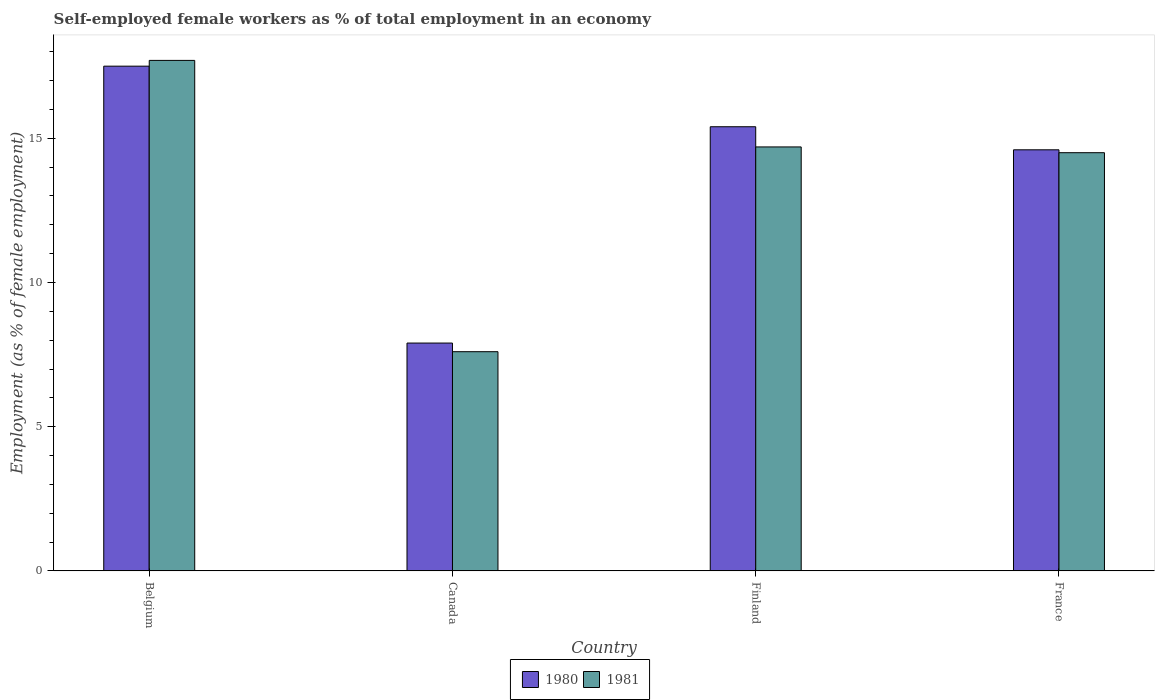How many different coloured bars are there?
Ensure brevity in your answer.  2. How many bars are there on the 1st tick from the right?
Offer a very short reply. 2. In how many cases, is the number of bars for a given country not equal to the number of legend labels?
Keep it short and to the point. 0. What is the percentage of self-employed female workers in 1980 in Finland?
Your answer should be compact. 15.4. Across all countries, what is the maximum percentage of self-employed female workers in 1981?
Provide a succinct answer. 17.7. Across all countries, what is the minimum percentage of self-employed female workers in 1981?
Keep it short and to the point. 7.6. In which country was the percentage of self-employed female workers in 1980 maximum?
Make the answer very short. Belgium. In which country was the percentage of self-employed female workers in 1981 minimum?
Offer a terse response. Canada. What is the total percentage of self-employed female workers in 1981 in the graph?
Make the answer very short. 54.5. What is the difference between the percentage of self-employed female workers in 1980 in Finland and that in France?
Your answer should be compact. 0.8. What is the difference between the percentage of self-employed female workers in 1981 in France and the percentage of self-employed female workers in 1980 in Canada?
Offer a very short reply. 6.6. What is the average percentage of self-employed female workers in 1980 per country?
Your answer should be very brief. 13.85. What is the difference between the percentage of self-employed female workers of/in 1980 and percentage of self-employed female workers of/in 1981 in Finland?
Ensure brevity in your answer.  0.7. What is the ratio of the percentage of self-employed female workers in 1981 in Belgium to that in France?
Your answer should be very brief. 1.22. Is the percentage of self-employed female workers in 1980 in Canada less than that in France?
Keep it short and to the point. Yes. Is the difference between the percentage of self-employed female workers in 1980 in Canada and France greater than the difference between the percentage of self-employed female workers in 1981 in Canada and France?
Offer a terse response. Yes. What is the difference between the highest and the second highest percentage of self-employed female workers in 1980?
Ensure brevity in your answer.  2.9. What is the difference between the highest and the lowest percentage of self-employed female workers in 1980?
Provide a short and direct response. 9.6. In how many countries, is the percentage of self-employed female workers in 1981 greater than the average percentage of self-employed female workers in 1981 taken over all countries?
Provide a short and direct response. 3. Is the sum of the percentage of self-employed female workers in 1981 in Finland and France greater than the maximum percentage of self-employed female workers in 1980 across all countries?
Your response must be concise. Yes. What does the 1st bar from the left in Canada represents?
Provide a short and direct response. 1980. Are all the bars in the graph horizontal?
Make the answer very short. No. How many countries are there in the graph?
Provide a short and direct response. 4. What is the difference between two consecutive major ticks on the Y-axis?
Ensure brevity in your answer.  5. Does the graph contain any zero values?
Your response must be concise. No. Where does the legend appear in the graph?
Offer a terse response. Bottom center. How are the legend labels stacked?
Give a very brief answer. Horizontal. What is the title of the graph?
Your answer should be very brief. Self-employed female workers as % of total employment in an economy. What is the label or title of the Y-axis?
Your response must be concise. Employment (as % of female employment). What is the Employment (as % of female employment) in 1981 in Belgium?
Provide a succinct answer. 17.7. What is the Employment (as % of female employment) of 1980 in Canada?
Ensure brevity in your answer.  7.9. What is the Employment (as % of female employment) of 1981 in Canada?
Give a very brief answer. 7.6. What is the Employment (as % of female employment) in 1980 in Finland?
Provide a short and direct response. 15.4. What is the Employment (as % of female employment) in 1981 in Finland?
Offer a very short reply. 14.7. What is the Employment (as % of female employment) of 1980 in France?
Your answer should be compact. 14.6. What is the Employment (as % of female employment) of 1981 in France?
Ensure brevity in your answer.  14.5. Across all countries, what is the maximum Employment (as % of female employment) in 1981?
Provide a short and direct response. 17.7. Across all countries, what is the minimum Employment (as % of female employment) in 1980?
Make the answer very short. 7.9. Across all countries, what is the minimum Employment (as % of female employment) of 1981?
Offer a terse response. 7.6. What is the total Employment (as % of female employment) of 1980 in the graph?
Ensure brevity in your answer.  55.4. What is the total Employment (as % of female employment) of 1981 in the graph?
Give a very brief answer. 54.5. What is the difference between the Employment (as % of female employment) in 1981 in Belgium and that in Canada?
Make the answer very short. 10.1. What is the difference between the Employment (as % of female employment) of 1981 in Canada and that in Finland?
Offer a terse response. -7.1. What is the difference between the Employment (as % of female employment) in 1980 in Belgium and the Employment (as % of female employment) in 1981 in Canada?
Your answer should be compact. 9.9. What is the difference between the Employment (as % of female employment) in 1980 in Belgium and the Employment (as % of female employment) in 1981 in France?
Offer a terse response. 3. What is the difference between the Employment (as % of female employment) of 1980 in Canada and the Employment (as % of female employment) of 1981 in France?
Make the answer very short. -6.6. What is the difference between the Employment (as % of female employment) in 1980 in Finland and the Employment (as % of female employment) in 1981 in France?
Make the answer very short. 0.9. What is the average Employment (as % of female employment) in 1980 per country?
Offer a terse response. 13.85. What is the average Employment (as % of female employment) of 1981 per country?
Your answer should be compact. 13.62. What is the difference between the Employment (as % of female employment) of 1980 and Employment (as % of female employment) of 1981 in France?
Your response must be concise. 0.1. What is the ratio of the Employment (as % of female employment) in 1980 in Belgium to that in Canada?
Make the answer very short. 2.22. What is the ratio of the Employment (as % of female employment) of 1981 in Belgium to that in Canada?
Provide a short and direct response. 2.33. What is the ratio of the Employment (as % of female employment) in 1980 in Belgium to that in Finland?
Keep it short and to the point. 1.14. What is the ratio of the Employment (as % of female employment) of 1981 in Belgium to that in Finland?
Ensure brevity in your answer.  1.2. What is the ratio of the Employment (as % of female employment) in 1980 in Belgium to that in France?
Ensure brevity in your answer.  1.2. What is the ratio of the Employment (as % of female employment) of 1981 in Belgium to that in France?
Offer a very short reply. 1.22. What is the ratio of the Employment (as % of female employment) in 1980 in Canada to that in Finland?
Offer a terse response. 0.51. What is the ratio of the Employment (as % of female employment) in 1981 in Canada to that in Finland?
Your response must be concise. 0.52. What is the ratio of the Employment (as % of female employment) of 1980 in Canada to that in France?
Offer a terse response. 0.54. What is the ratio of the Employment (as % of female employment) of 1981 in Canada to that in France?
Your answer should be compact. 0.52. What is the ratio of the Employment (as % of female employment) of 1980 in Finland to that in France?
Your answer should be very brief. 1.05. What is the ratio of the Employment (as % of female employment) in 1981 in Finland to that in France?
Your answer should be compact. 1.01. 